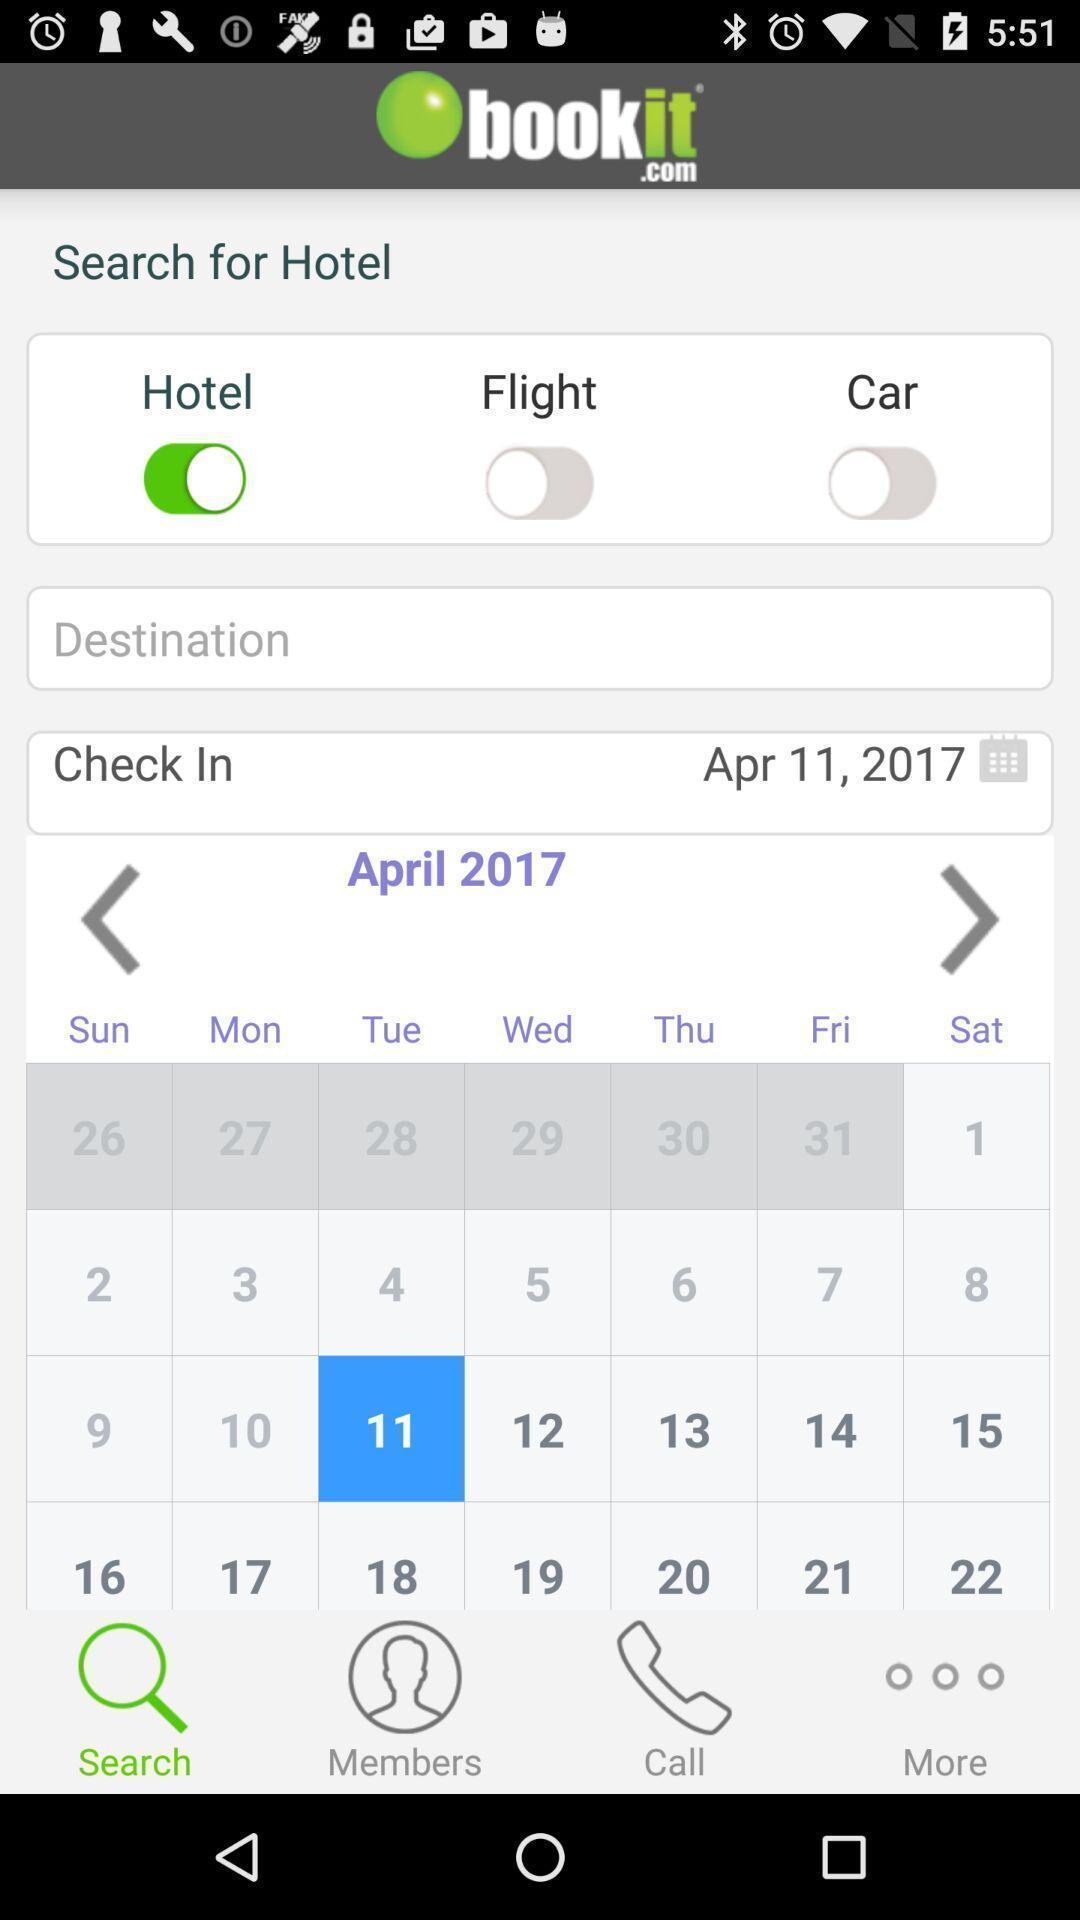Tell me about the visual elements in this screen capture. Search page to search for hotel. 